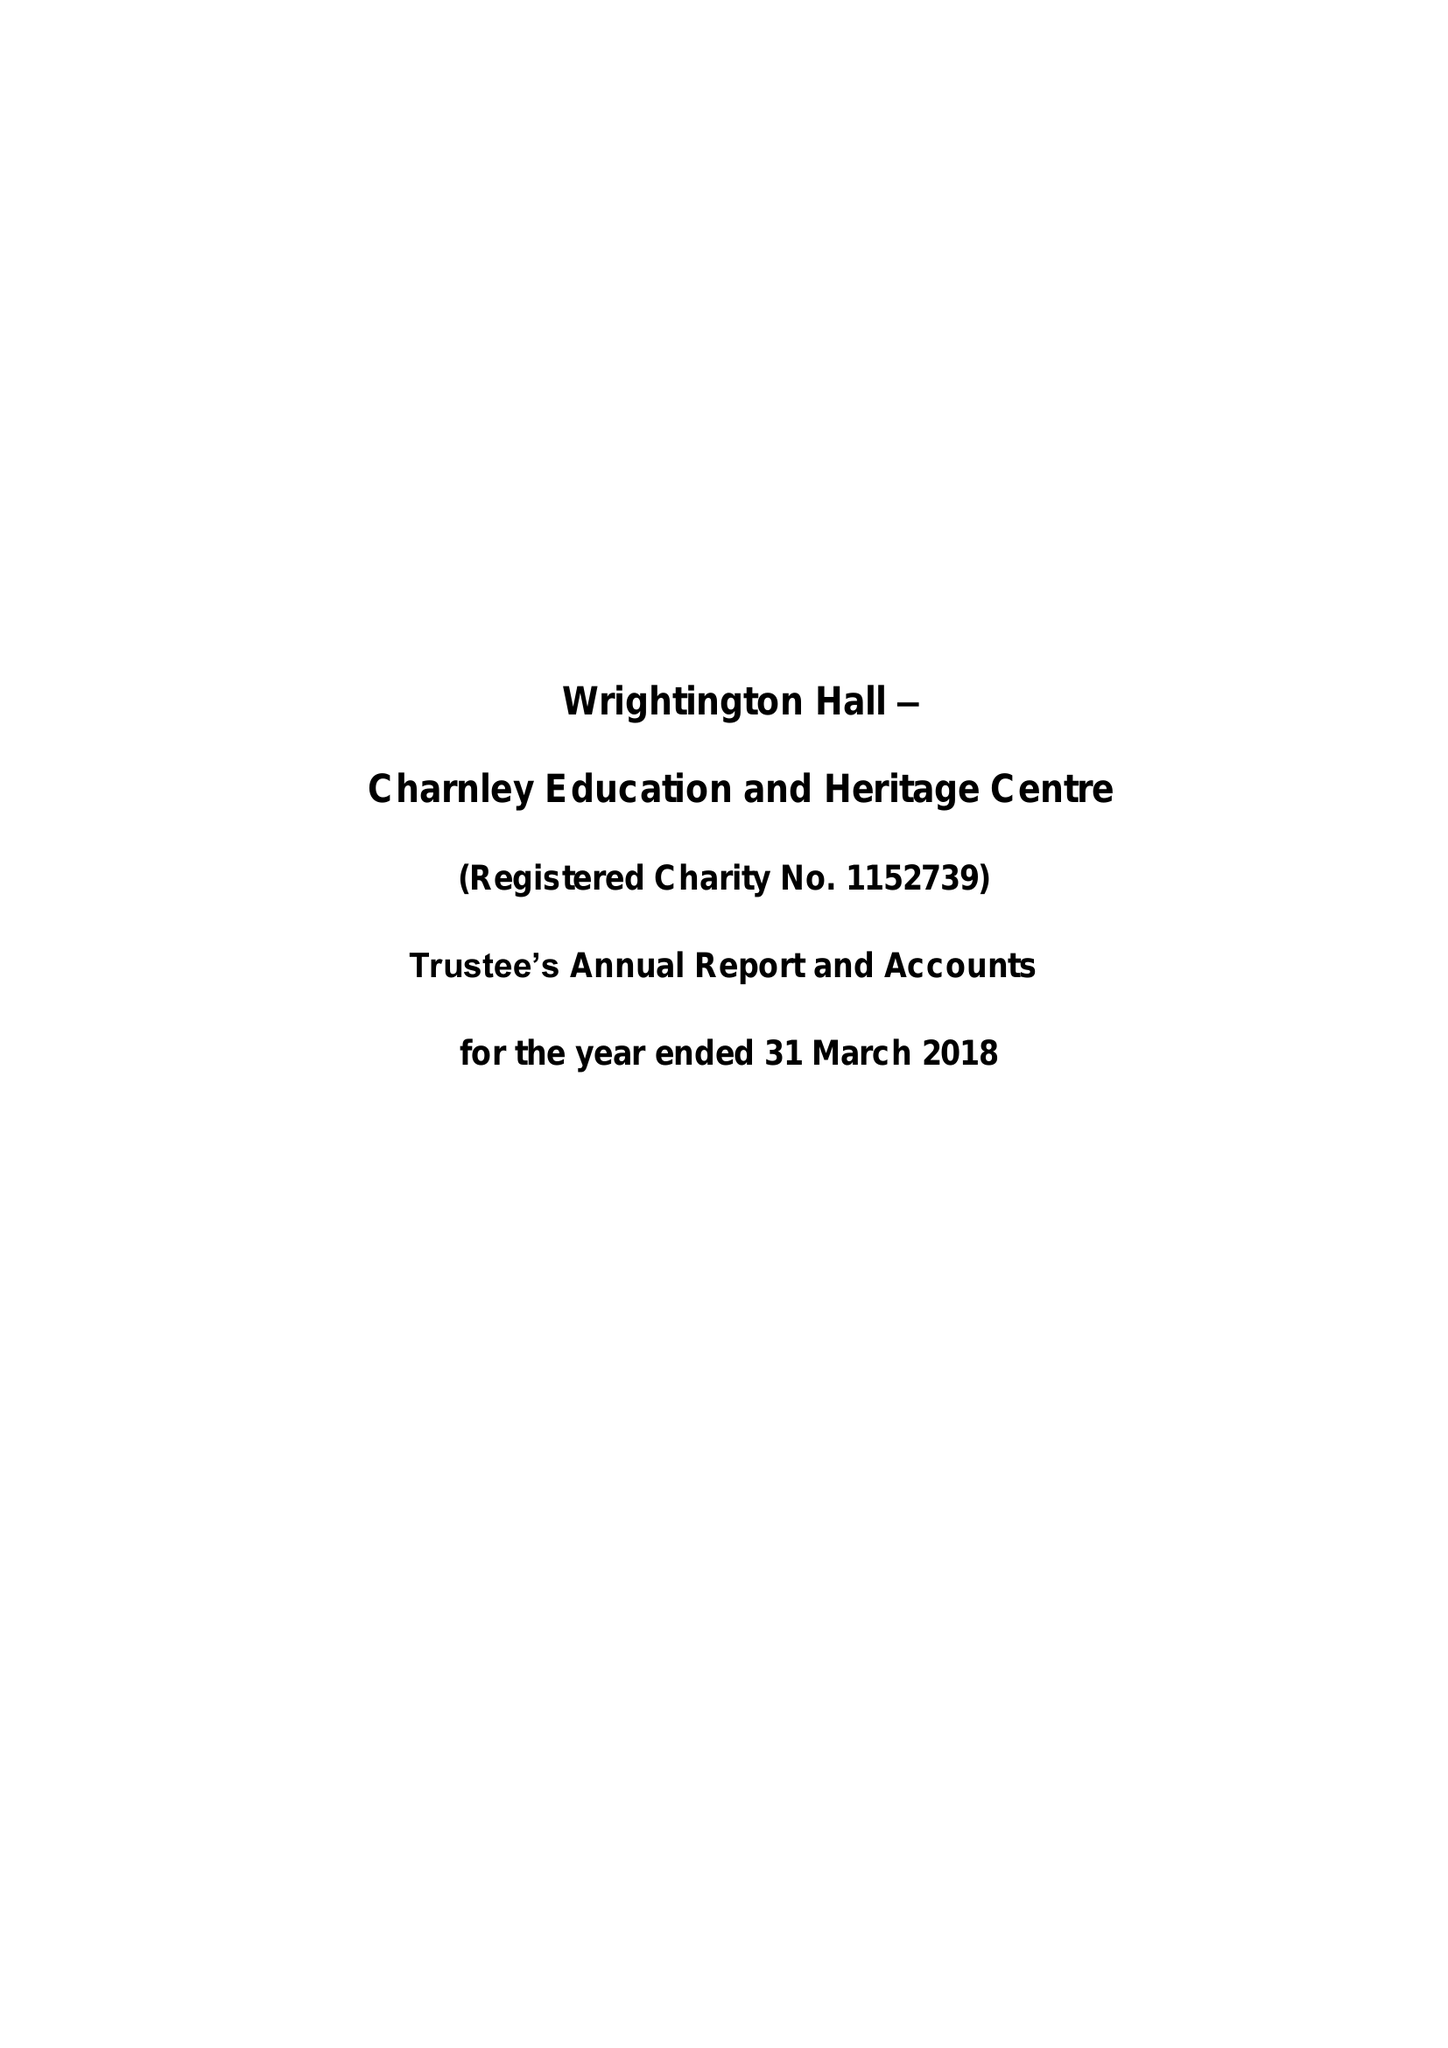What is the value for the report_date?
Answer the question using a single word or phrase. 2018-03-31 